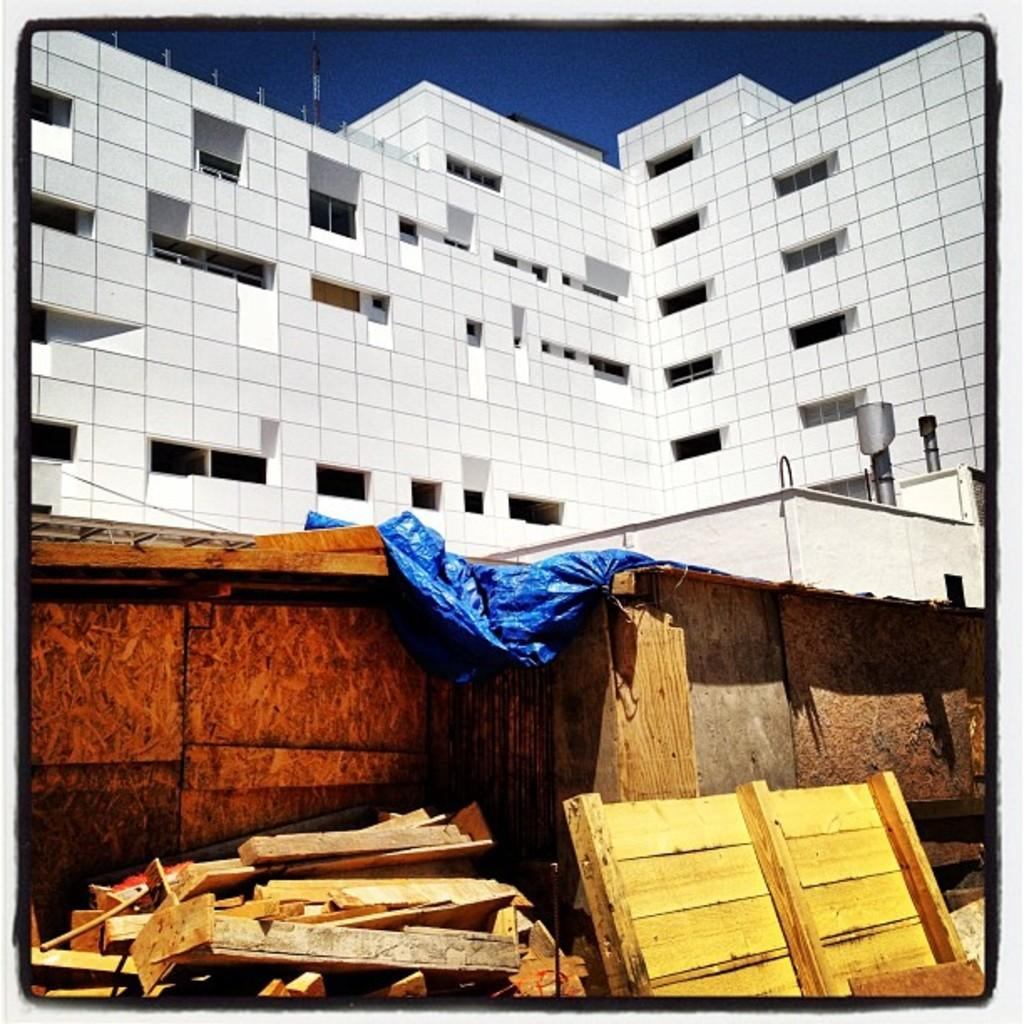What type of natural environment is present at the bottom of the image? There are woods at the bottom of the image. What type of structure is located at the top of the image? There is a big building at the top of the image. What industry is depicted in the image? There is no specific industry depicted in the image; it only shows woods at the bottom and a big building at the top. What emotion is the woods expressing in the image? The woods, being an inanimate object, do not express emotions like fear. 